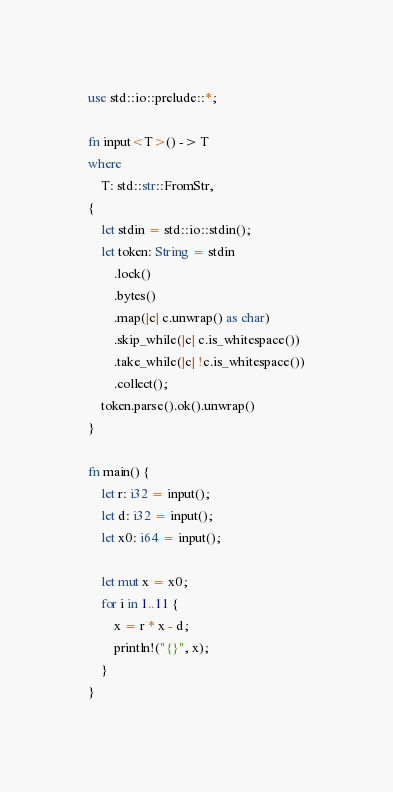Convert code to text. <code><loc_0><loc_0><loc_500><loc_500><_Rust_>use std::io::prelude::*;

fn input<T>() -> T
where
    T: std::str::FromStr,
{
    let stdin = std::io::stdin();
    let token: String = stdin
        .lock()
        .bytes()
        .map(|c| c.unwrap() as char)
        .skip_while(|c| c.is_whitespace())
        .take_while(|c| !c.is_whitespace())
        .collect();
    token.parse().ok().unwrap()
}

fn main() {
    let r: i32 = input();
    let d: i32 = input();
    let x0: i64 = input();

    let mut x = x0;
    for i in 1..11 {
        x = r * x - d;
        println!("{}", x);
    }
}
</code> 